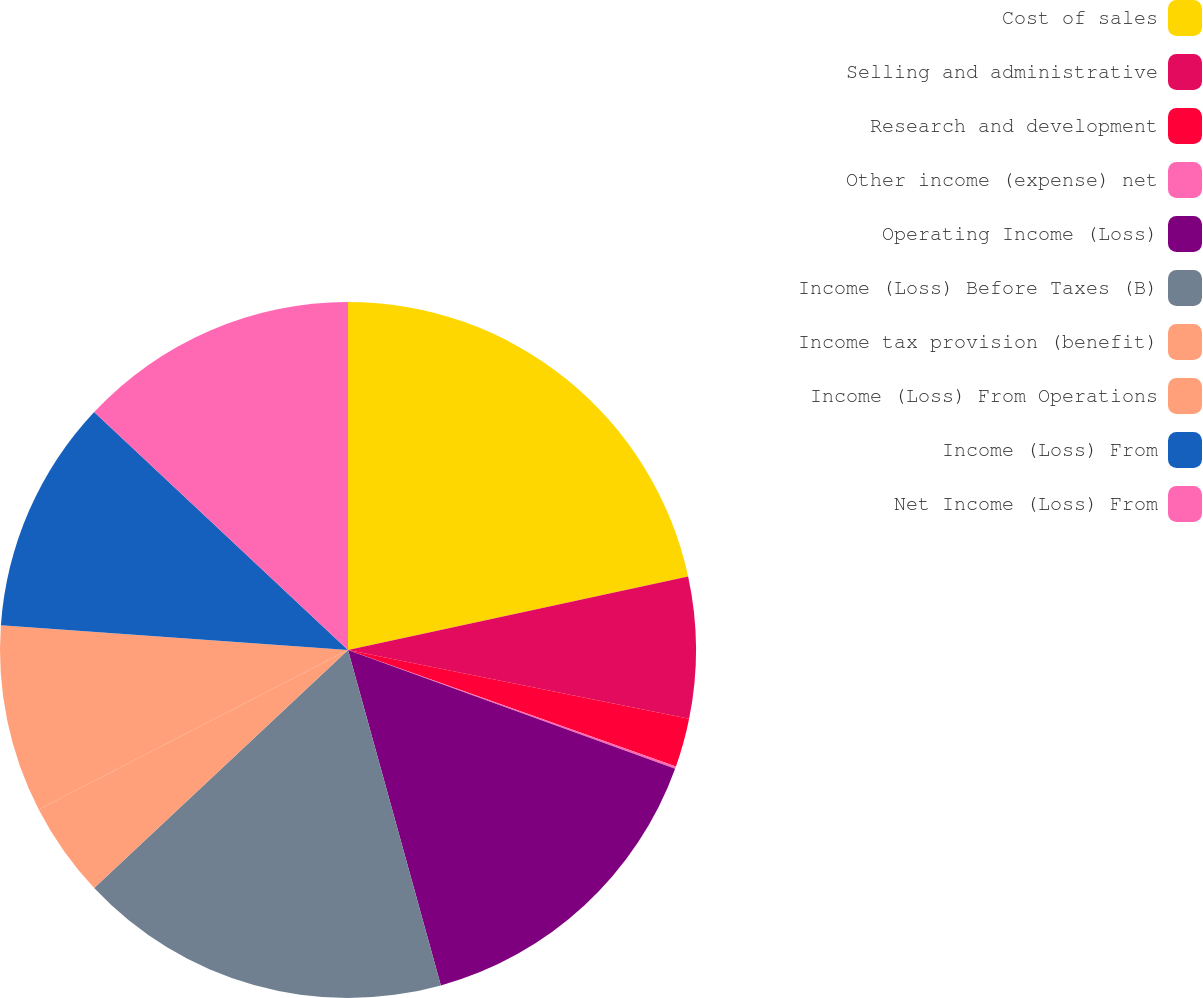Convert chart to OTSL. <chart><loc_0><loc_0><loc_500><loc_500><pie_chart><fcel>Cost of sales<fcel>Selling and administrative<fcel>Research and development<fcel>Other income (expense) net<fcel>Operating Income (Loss)<fcel>Income (Loss) Before Taxes (B)<fcel>Income tax provision (benefit)<fcel>Income (Loss) From Operations<fcel>Income (Loss) From<fcel>Net Income (Loss) From<nl><fcel>21.61%<fcel>6.56%<fcel>2.26%<fcel>0.11%<fcel>15.16%<fcel>17.31%<fcel>4.41%<fcel>8.71%<fcel>10.86%<fcel>13.01%<nl></chart> 